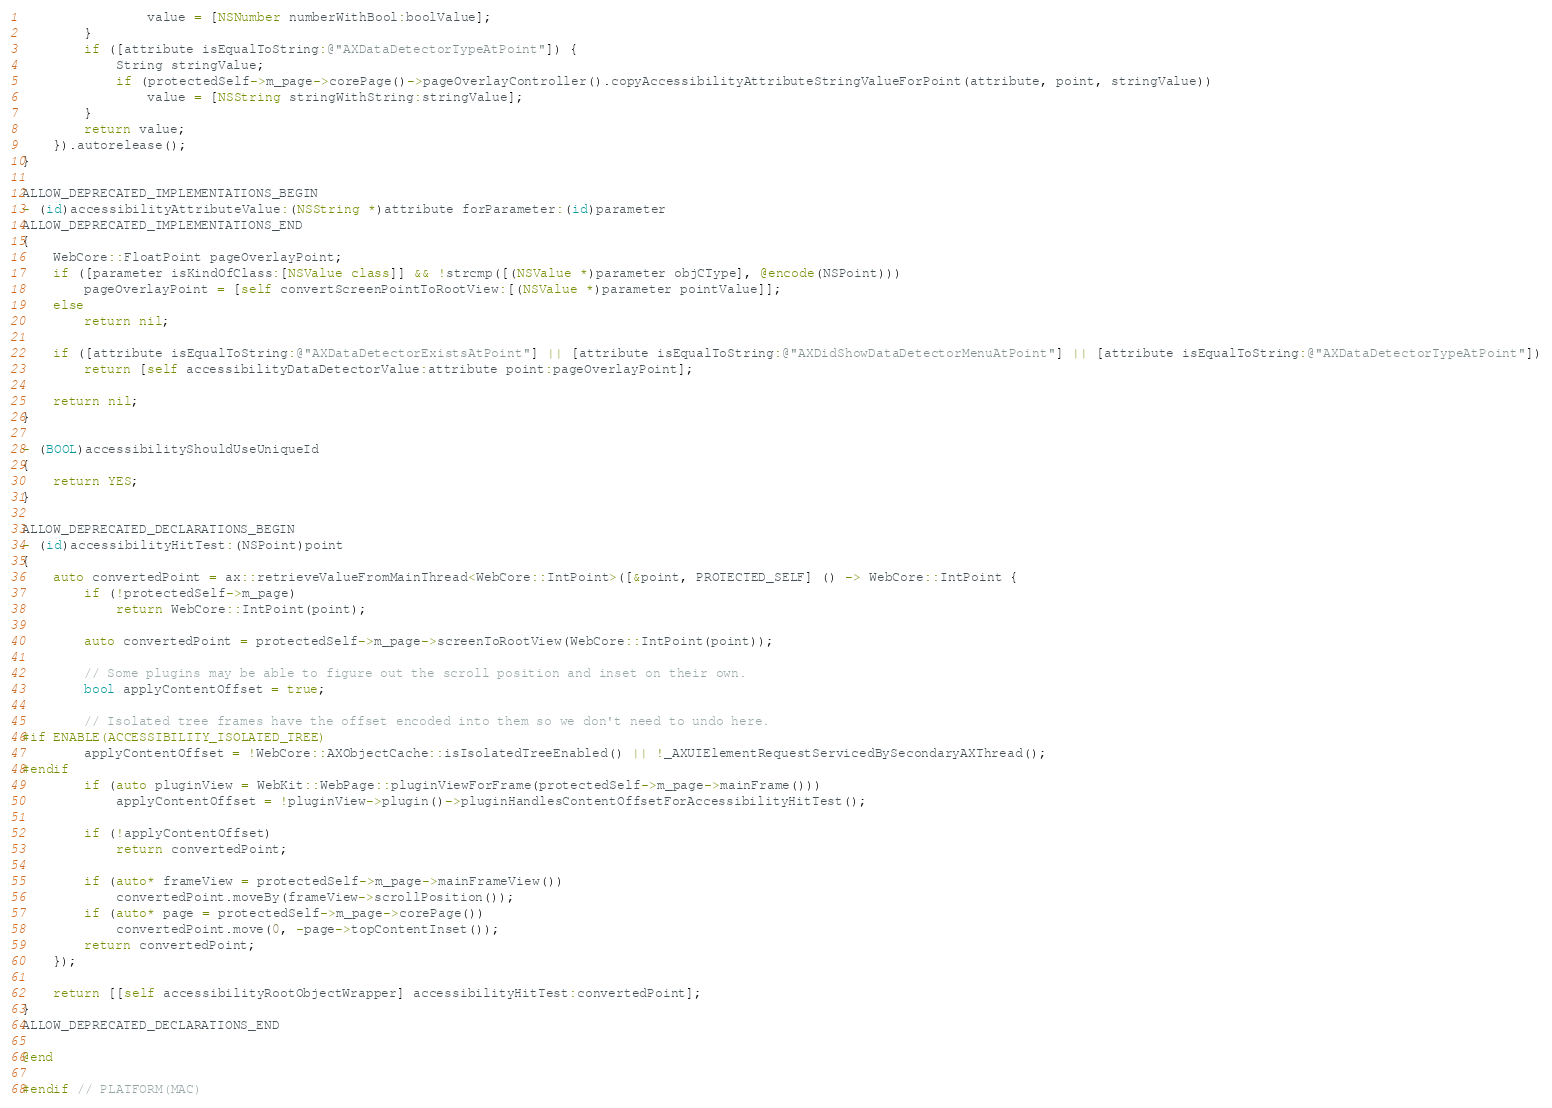Convert code to text. <code><loc_0><loc_0><loc_500><loc_500><_ObjectiveC_>                value = [NSNumber numberWithBool:boolValue];
        }
        if ([attribute isEqualToString:@"AXDataDetectorTypeAtPoint"]) {
            String stringValue;
            if (protectedSelf->m_page->corePage()->pageOverlayController().copyAccessibilityAttributeStringValueForPoint(attribute, point, stringValue))
                value = [NSString stringWithString:stringValue];
        }
        return value;
    }).autorelease();
}

ALLOW_DEPRECATED_IMPLEMENTATIONS_BEGIN
- (id)accessibilityAttributeValue:(NSString *)attribute forParameter:(id)parameter
ALLOW_DEPRECATED_IMPLEMENTATIONS_END
{
    WebCore::FloatPoint pageOverlayPoint;
    if ([parameter isKindOfClass:[NSValue class]] && !strcmp([(NSValue *)parameter objCType], @encode(NSPoint)))
        pageOverlayPoint = [self convertScreenPointToRootView:[(NSValue *)parameter pointValue]];
    else
        return nil;

    if ([attribute isEqualToString:@"AXDataDetectorExistsAtPoint"] || [attribute isEqualToString:@"AXDidShowDataDetectorMenuAtPoint"] || [attribute isEqualToString:@"AXDataDetectorTypeAtPoint"])
        return [self accessibilityDataDetectorValue:attribute point:pageOverlayPoint];

    return nil;
}

- (BOOL)accessibilityShouldUseUniqueId
{
    return YES;
}

ALLOW_DEPRECATED_DECLARATIONS_BEGIN
- (id)accessibilityHitTest:(NSPoint)point
{
    auto convertedPoint = ax::retrieveValueFromMainThread<WebCore::IntPoint>([&point, PROTECTED_SELF] () -> WebCore::IntPoint {
        if (!protectedSelf->m_page)
            return WebCore::IntPoint(point);

        auto convertedPoint = protectedSelf->m_page->screenToRootView(WebCore::IntPoint(point));

        // Some plugins may be able to figure out the scroll position and inset on their own.
        bool applyContentOffset = true;

        // Isolated tree frames have the offset encoded into them so we don't need to undo here.
#if ENABLE(ACCESSIBILITY_ISOLATED_TREE)
        applyContentOffset = !WebCore::AXObjectCache::isIsolatedTreeEnabled() || !_AXUIElementRequestServicedBySecondaryAXThread();
#endif
        if (auto pluginView = WebKit::WebPage::pluginViewForFrame(protectedSelf->m_page->mainFrame()))
            applyContentOffset = !pluginView->plugin()->pluginHandlesContentOffsetForAccessibilityHitTest();
        
        if (!applyContentOffset)
            return convertedPoint;

        if (auto* frameView = protectedSelf->m_page->mainFrameView())
            convertedPoint.moveBy(frameView->scrollPosition());
        if (auto* page = protectedSelf->m_page->corePage())
            convertedPoint.move(0, -page->topContentInset());
        return convertedPoint;
    });
    
    return [[self accessibilityRootObjectWrapper] accessibilityHitTest:convertedPoint];
}
ALLOW_DEPRECATED_DECLARATIONS_END

@end

#endif // PLATFORM(MAC)

</code> 